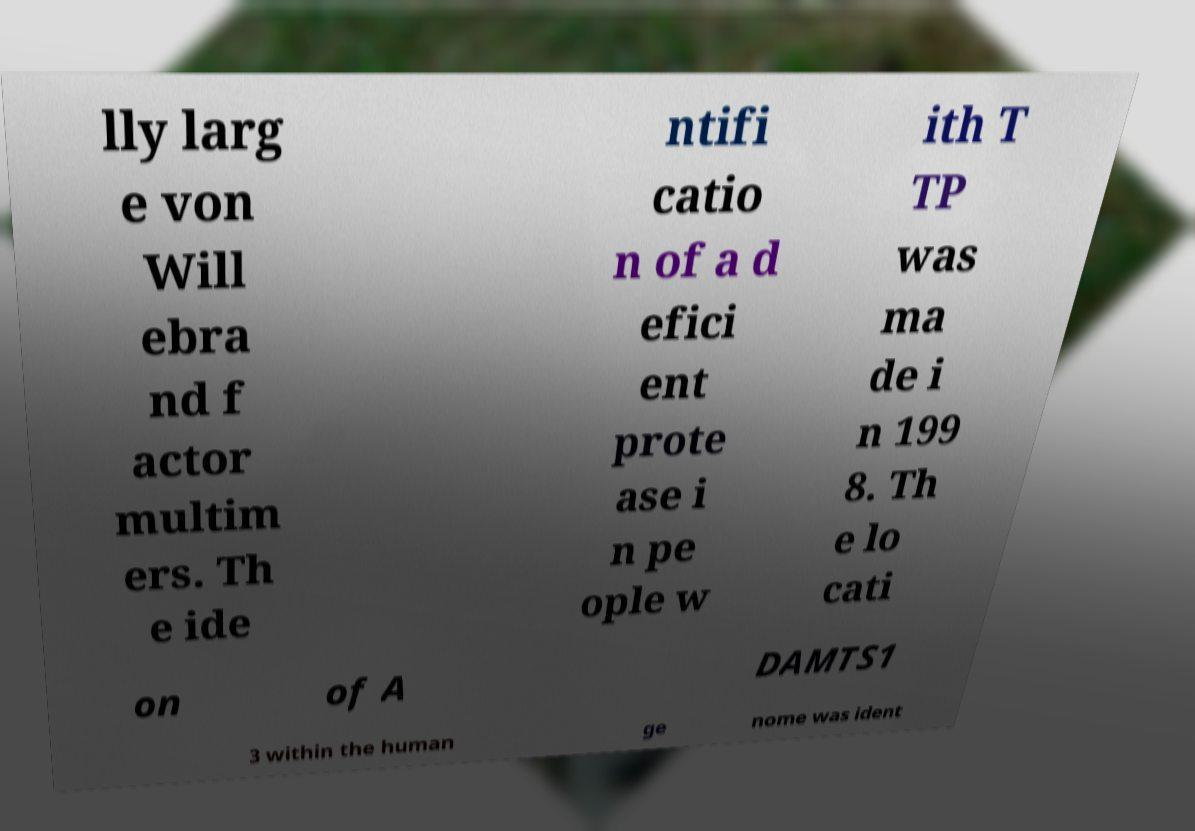For documentation purposes, I need the text within this image transcribed. Could you provide that? lly larg e von Will ebra nd f actor multim ers. Th e ide ntifi catio n of a d efici ent prote ase i n pe ople w ith T TP was ma de i n 199 8. Th e lo cati on of A DAMTS1 3 within the human ge nome was ident 